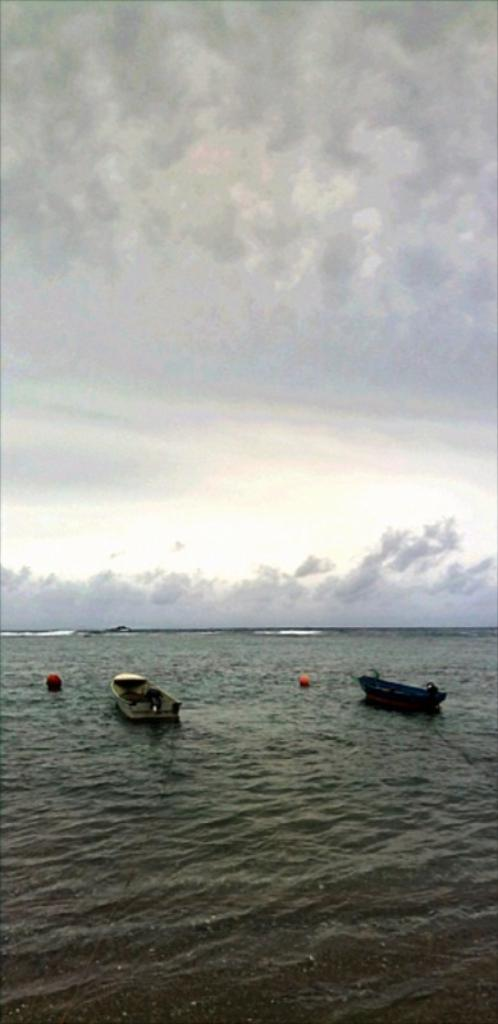What type of vehicles are at the bottom of the image? There are boats at the bottom of the image. Where are the boats located? The boats are on a river. What can be seen in the background of the image? There is sky visible in the background of the image. How many icicles are hanging from the boats in the image? There are no icicles present in the image; it features boats on a river with sky visible in the background. 